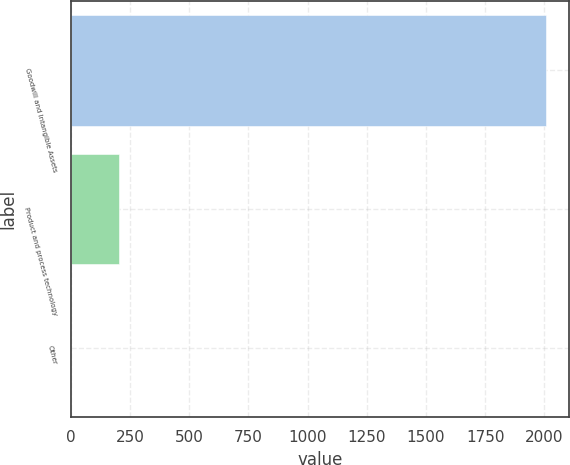Convert chart. <chart><loc_0><loc_0><loc_500><loc_500><bar_chart><fcel>Goodwill and Intangible Assets<fcel>Product and process technology<fcel>Other<nl><fcel>2005<fcel>202.3<fcel>2<nl></chart> 